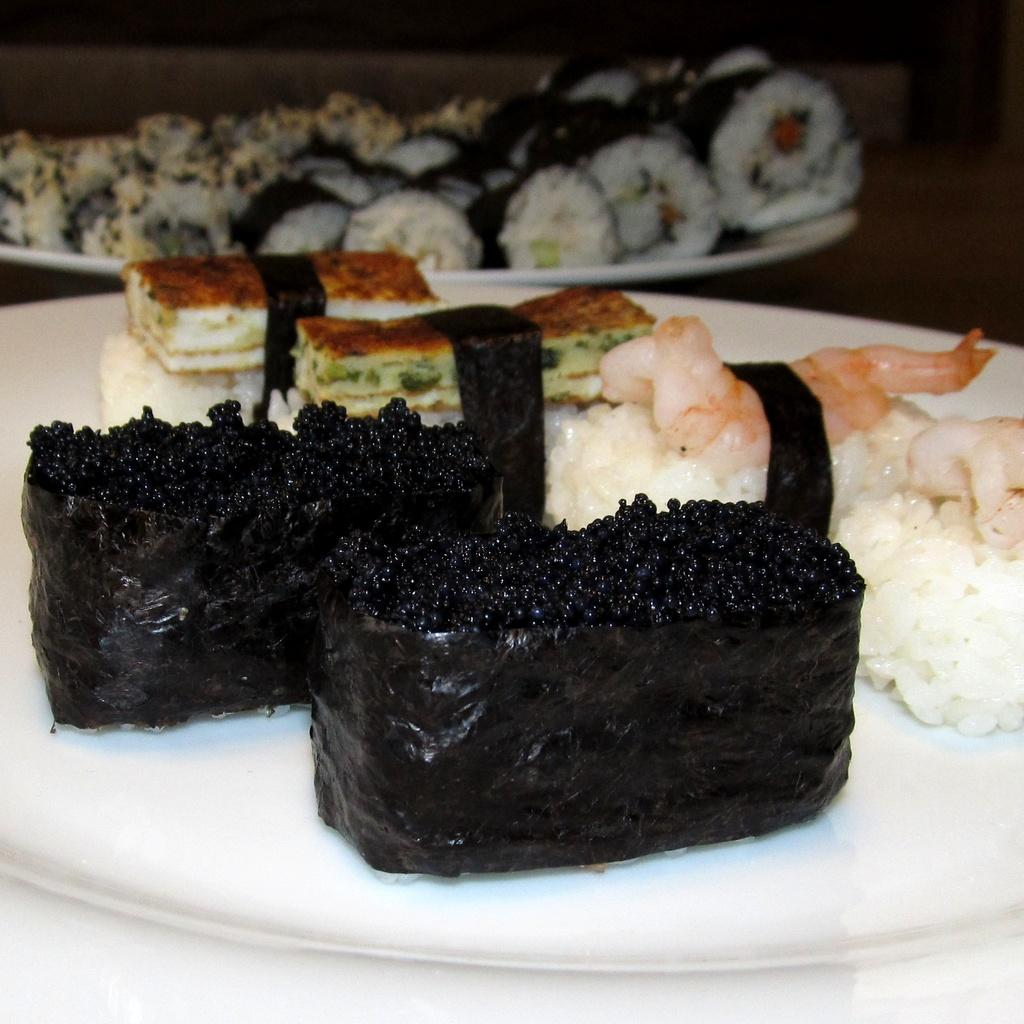How many plates are visible in the image? There are two plates in the image. What color are the plates? The plates are white in color. What can be found on the plates? There are food items on the plates. What type of quartz can be seen on the plates in the image? There is no quartz present on the plates in the image. How many cats are sitting on the plates in the image? There are no cats present on the plates in the image. 